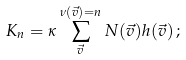Convert formula to latex. <formula><loc_0><loc_0><loc_500><loc_500>K _ { n } = \kappa \sum _ { \vec { v } } ^ { \nu ( \vec { v } ) = n } N ( \vec { v } ) h ( \vec { v } ) \, ;</formula> 